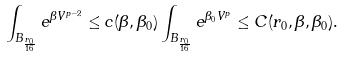<formula> <loc_0><loc_0><loc_500><loc_500>\int _ { B _ { \frac { r _ { 0 } } { 1 6 } } } e ^ { \beta V ^ { p - 2 } } \leq c ( \beta , \beta _ { 0 } ) \int _ { B _ { \frac { r _ { 0 } } { 1 6 } } } e ^ { \beta _ { 0 } V ^ { p } } \leq C ( r _ { 0 } , \beta , \beta _ { 0 } ) .</formula> 